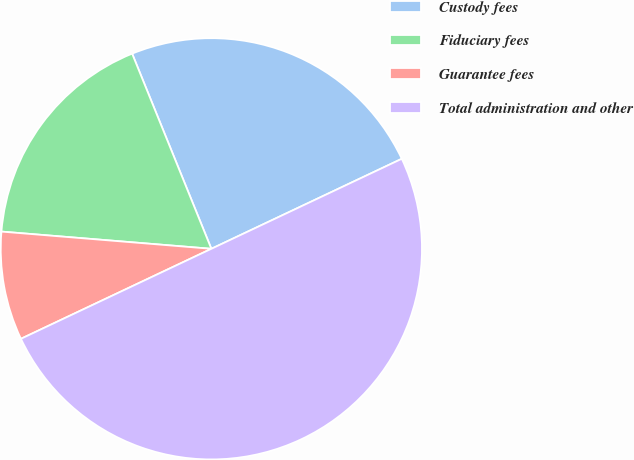<chart> <loc_0><loc_0><loc_500><loc_500><pie_chart><fcel>Custody fees<fcel>Fiduciary fees<fcel>Guarantee fees<fcel>Total administration and other<nl><fcel>24.11%<fcel>17.56%<fcel>8.33%<fcel>50.0%<nl></chart> 